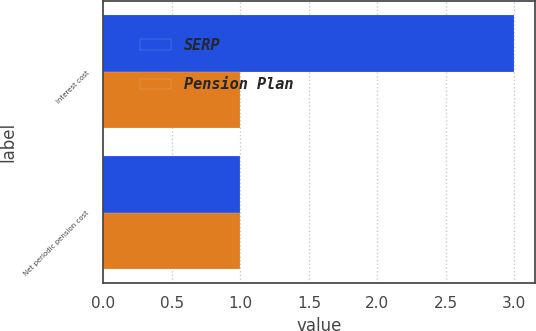Convert chart to OTSL. <chart><loc_0><loc_0><loc_500><loc_500><stacked_bar_chart><ecel><fcel>Interest cost<fcel>Net periodic pension cost<nl><fcel>SERP<fcel>3<fcel>1<nl><fcel>Pension Plan<fcel>1<fcel>1<nl></chart> 